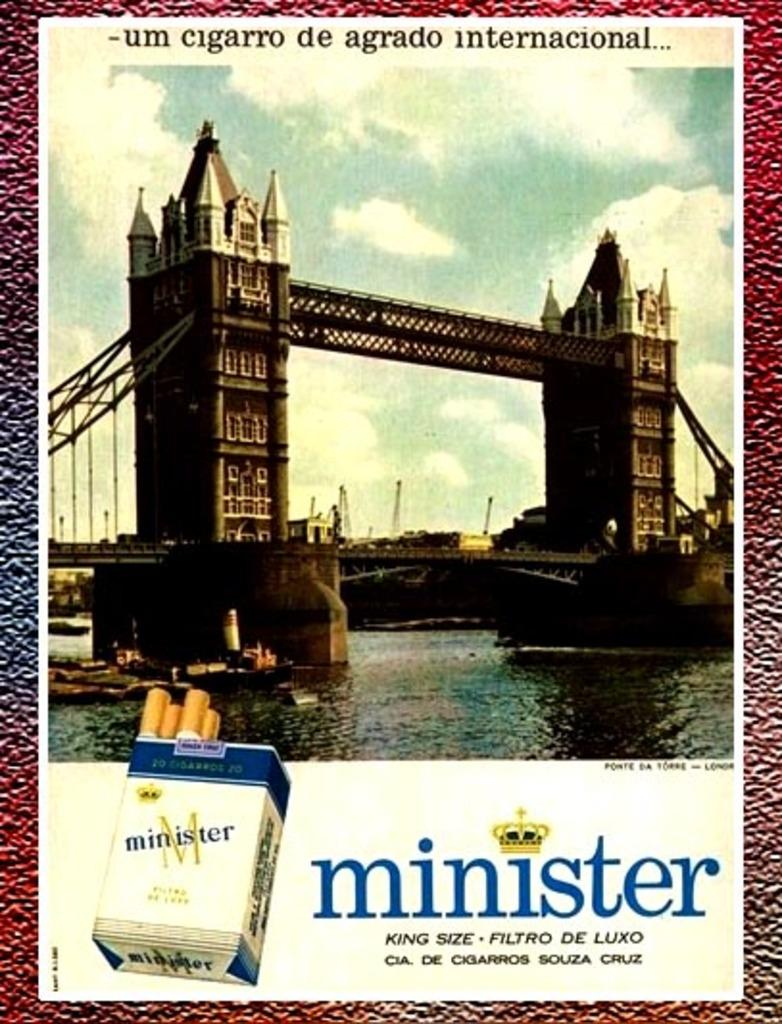Provide a one-sentence caption for the provided image. An ad for minister cigarettes shows a bridge and water on it. 